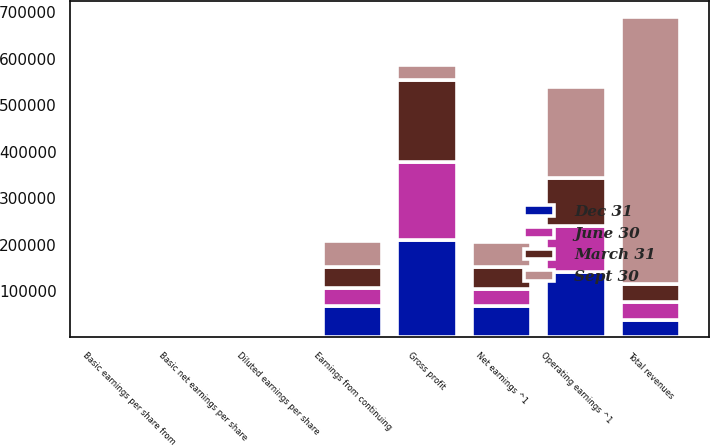Convert chart to OTSL. <chart><loc_0><loc_0><loc_500><loc_500><stacked_bar_chart><ecel><fcel>Total revenues<fcel>Gross profit<fcel>Operating earnings ^1<fcel>Earnings from continuing<fcel>Net earnings ^1<fcel>Basic earnings per share from<fcel>Diluted earnings per share<fcel>Basic net earnings per share<nl><fcel>Sept 30<fcel>574420<fcel>34092<fcel>194669<fcel>54505<fcel>53995<fcel>0.42<fcel>0.41<fcel>0.41<nl><fcel>March 31<fcel>38349<fcel>174788<fcel>103246<fcel>46511<fcel>45967<fcel>0.35<fcel>0.35<fcel>0.35<nl><fcel>Dec 31<fcel>38349<fcel>209042<fcel>140331<fcel>67781<fcel>66939<fcel>0.51<fcel>0.51<fcel>0.51<nl><fcel>June 30<fcel>38349<fcel>169660<fcel>99892<fcel>38349<fcel>38022<fcel>0.29<fcel>0.29<fcel>0.29<nl></chart> 